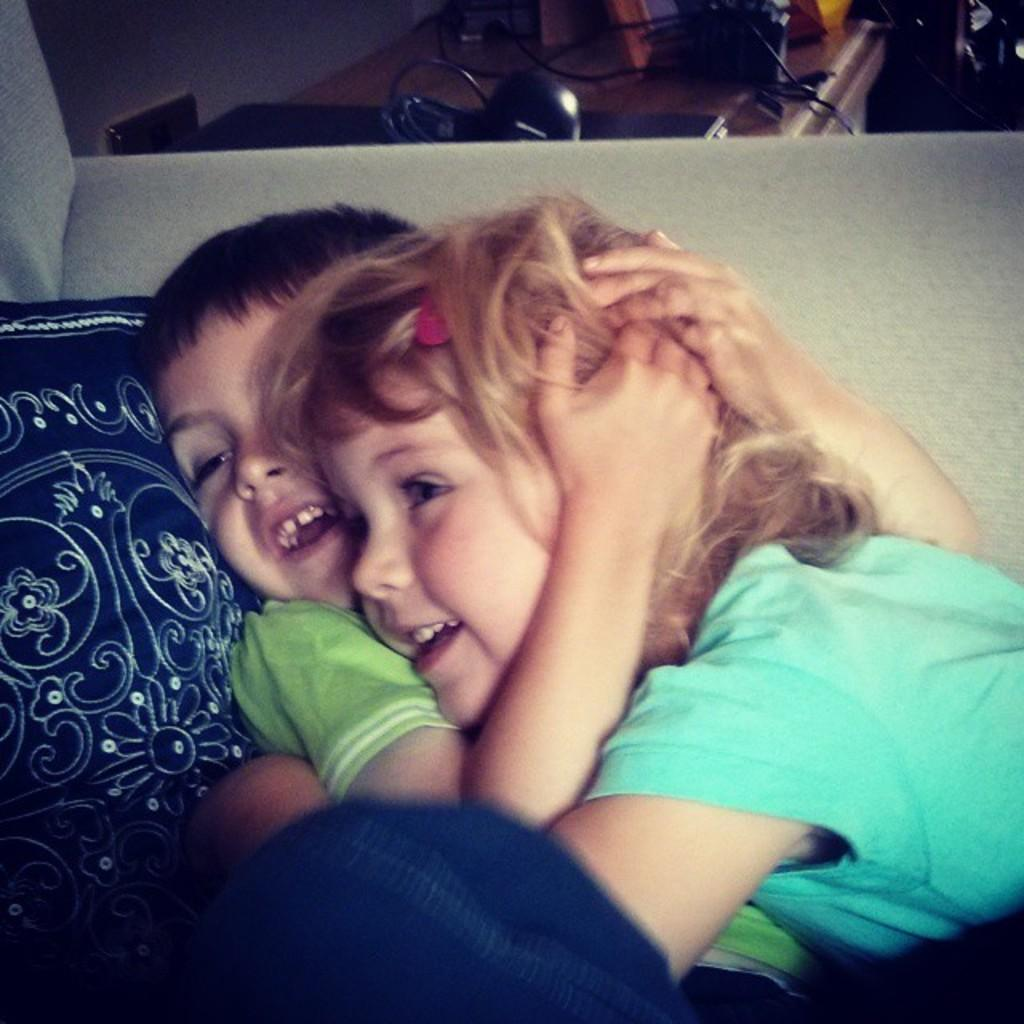How many people are in the image? There are two people in the image. What is the facial expression of the people in the image? Both people are smiling. What are the people wearing in the image? The people are wearing different color dresses. What can be seen in the background of the image? There are objects on a table and a navy blue color cloth in the background. What type of wax is being used in the image? There is no wax present in the image. 